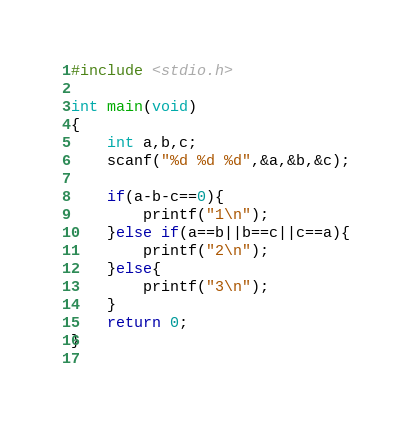<code> <loc_0><loc_0><loc_500><loc_500><_C_>#include <stdio.h>

int main(void)
{
	int a,b,c;
	scanf("%d %d %d",&a,&b,&c);
	
	if(a-b-c==0){
		printf("1\n");
	}else if(a==b||b==c||c==a){
		printf("2\n");
	}else{
		printf("3\n");
	}
	return 0;
}
	</code> 